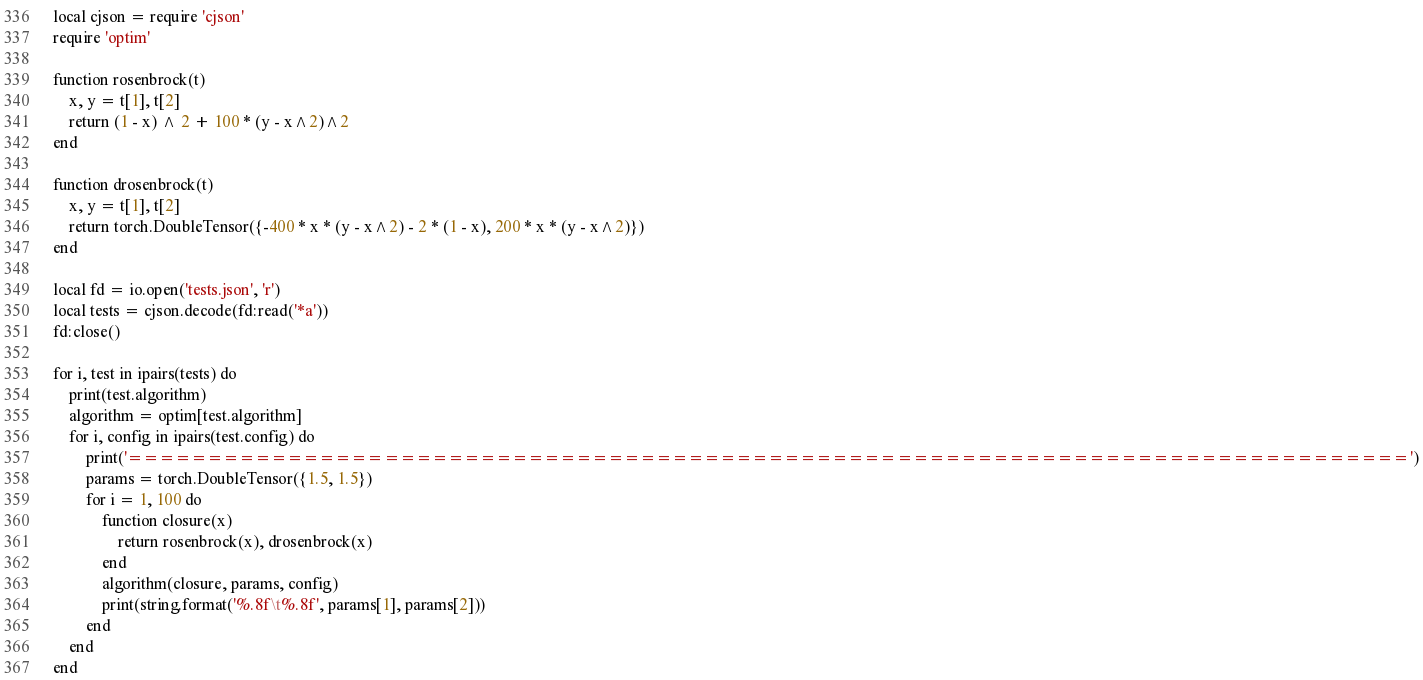Convert code to text. <code><loc_0><loc_0><loc_500><loc_500><_Lua_>local cjson = require 'cjson'
require 'optim'

function rosenbrock(t)
    x, y = t[1], t[2]
    return (1 - x) ^ 2 + 100 * (y - x^2)^2
end

function drosenbrock(t)
    x, y = t[1], t[2]
    return torch.DoubleTensor({-400 * x * (y - x^2) - 2 * (1 - x), 200 * x * (y - x^2)})
end

local fd = io.open('tests.json', 'r')
local tests = cjson.decode(fd:read('*a'))
fd:close()

for i, test in ipairs(tests) do
    print(test.algorithm)
    algorithm = optim[test.algorithm]
    for i, config in ipairs(test.config) do
        print('================================================================================')
        params = torch.DoubleTensor({1.5, 1.5})
        for i = 1, 100 do
            function closure(x)
                return rosenbrock(x), drosenbrock(x)
            end
            algorithm(closure, params, config)
            print(string.format('%.8f\t%.8f', params[1], params[2]))
        end
    end
end

</code> 